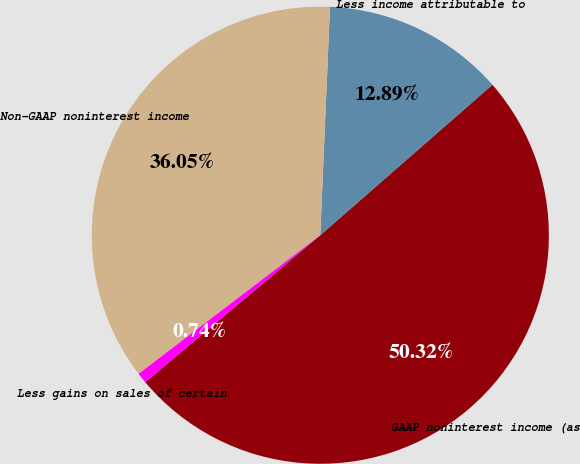Convert chart. <chart><loc_0><loc_0><loc_500><loc_500><pie_chart><fcel>GAAP noninterest income (as<fcel>Less income attributable to<fcel>Non-GAAP noninterest income<fcel>Less gains on sales of certain<nl><fcel>50.32%<fcel>12.89%<fcel>36.05%<fcel>0.74%<nl></chart> 